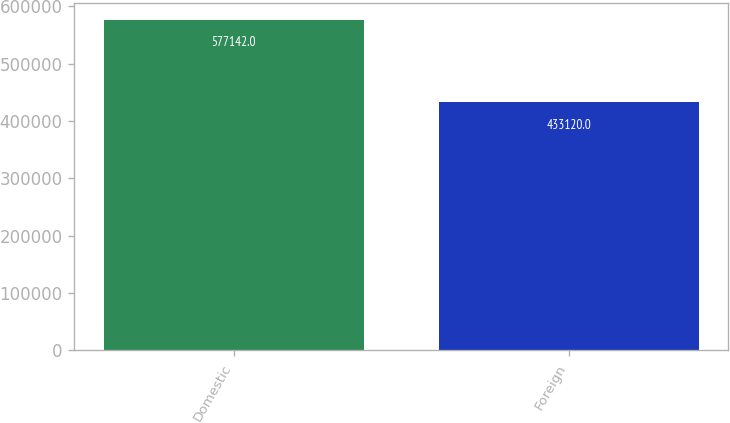<chart> <loc_0><loc_0><loc_500><loc_500><bar_chart><fcel>Domestic<fcel>Foreign<nl><fcel>577142<fcel>433120<nl></chart> 